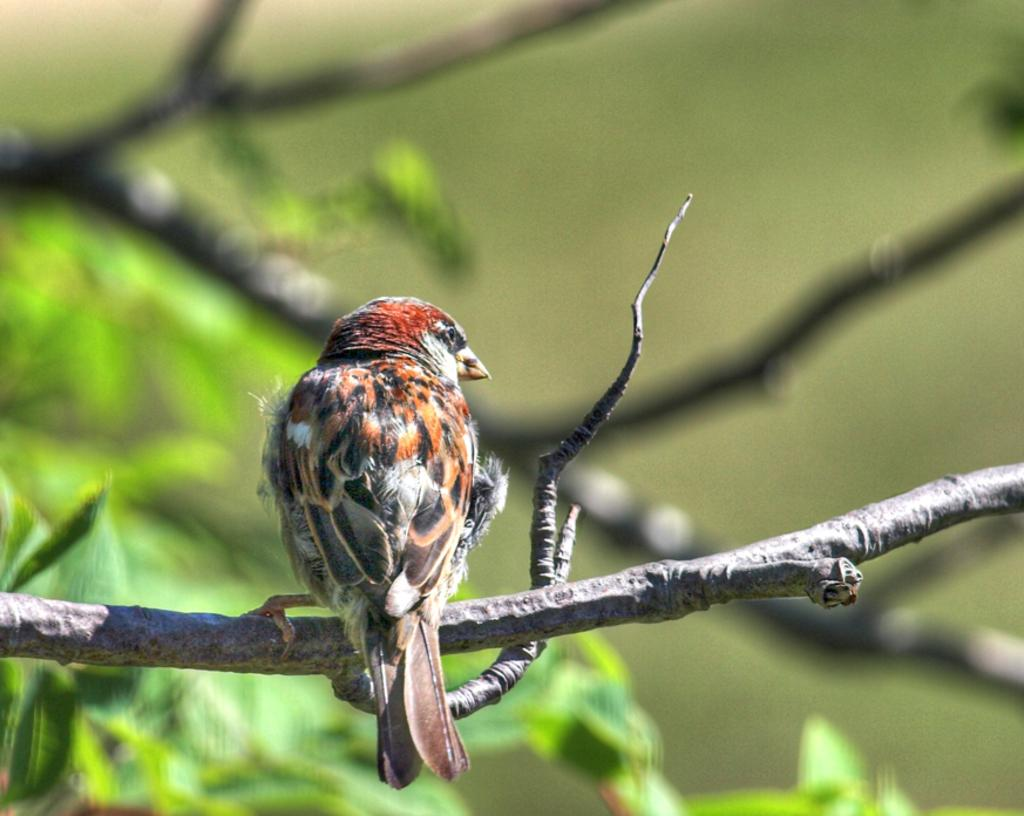What type of animal can be seen in the image? There is a bird in the image. Where is the bird located in the image? The bird is on the branch of a tree. What else can be seen in the background of the image? There are leaves and branches of a tree visible in the background of the image. What type of match is the bird holding in its beak in the image? There is no match present in the image; the bird is not holding anything in its beak. 